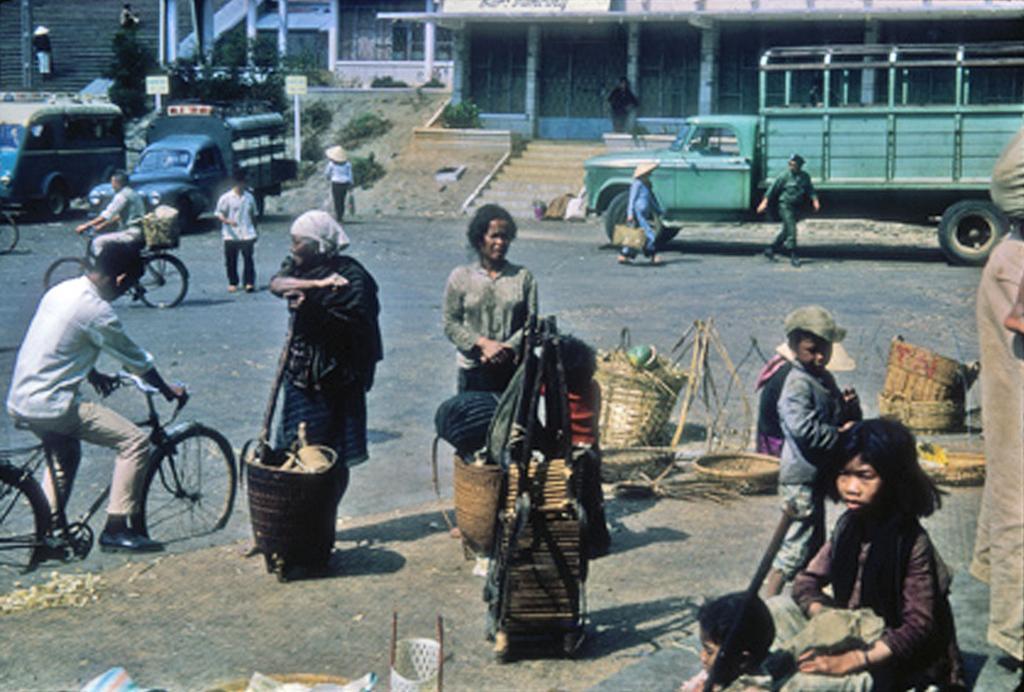In one or two sentences, can you explain what this image depicts? An outdoor picture. Vehicles on road. Most of the persons are standing. This person is sitting on a bicycle. This person is walking, as there is a leg movement. These are baskets. Far there are plants. This is a building. 